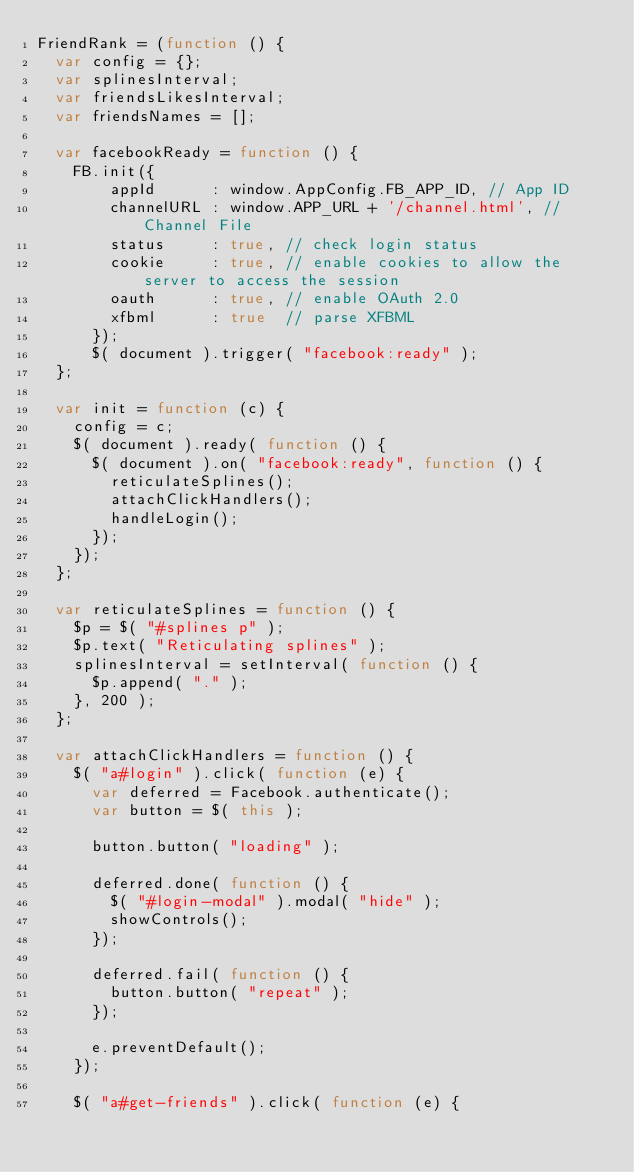<code> <loc_0><loc_0><loc_500><loc_500><_JavaScript_>FriendRank = (function () {
  var config = {};
  var splinesInterval;
  var friendsLikesInterval;
  var friendsNames = [];

  var facebookReady = function () {
    FB.init({
        appId      : window.AppConfig.FB_APP_ID, // App ID
        channelURL : window.APP_URL + '/channel.html', // Channel File
        status     : true, // check login status
        cookie     : true, // enable cookies to allow the server to access the session
        oauth      : true, // enable OAuth 2.0
        xfbml      : true  // parse XFBML
      });
      $( document ).trigger( "facebook:ready" );
  };

  var init = function (c) {
    config = c;
    $( document ).ready( function () {
      $( document ).on( "facebook:ready", function () {
        reticulateSplines();
        attachClickHandlers();
        handleLogin();
      });
    });
  };

  var reticulateSplines = function () {
    $p = $( "#splines p" );
    $p.text( "Reticulating splines" );
    splinesInterval = setInterval( function () {
      $p.append( "." );
    }, 200 );
  };

  var attachClickHandlers = function () {
    $( "a#login" ).click( function (e) {
      var deferred = Facebook.authenticate();
      var button = $( this );

      button.button( "loading" );

      deferred.done( function () {
        $( "#login-modal" ).modal( "hide" );
        showControls();
      });

      deferred.fail( function () {
        button.button( "repeat" );
      });

      e.preventDefault();
    });

    $( "a#get-friends" ).click( function (e) {</code> 